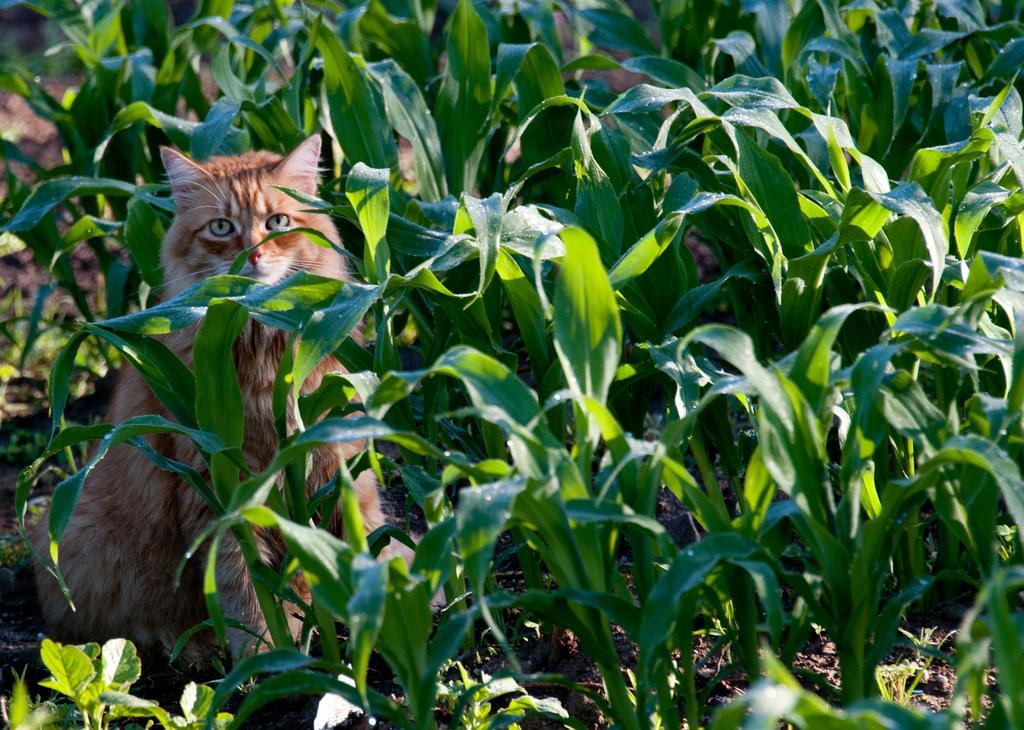Could you give a brief overview of what you see in this image? In this picture there is a cat sitting in between few green plants. 